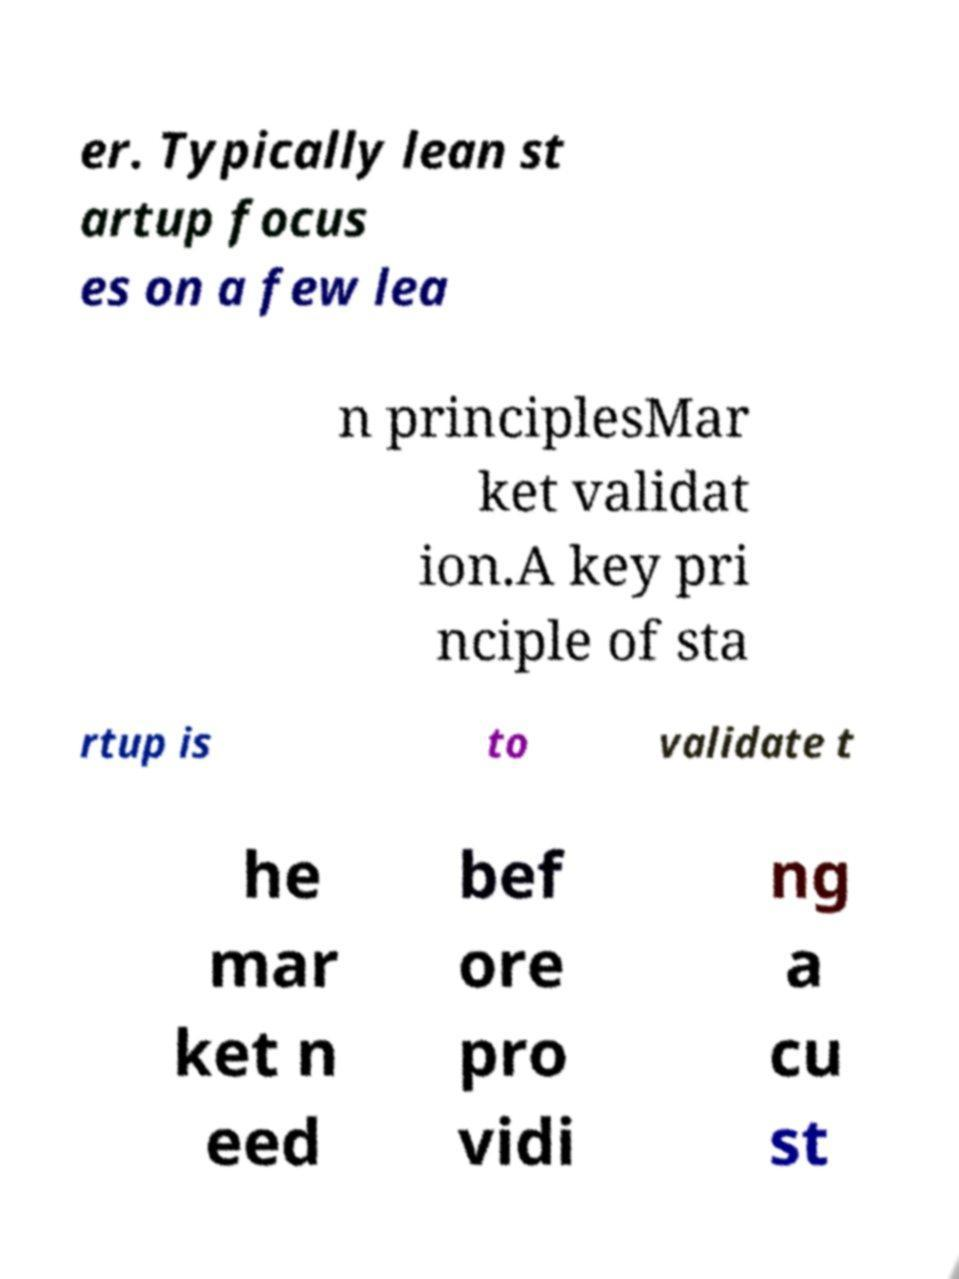For documentation purposes, I need the text within this image transcribed. Could you provide that? er. Typically lean st artup focus es on a few lea n principlesMar ket validat ion.A key pri nciple of sta rtup is to validate t he mar ket n eed bef ore pro vidi ng a cu st 